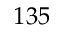<formula> <loc_0><loc_0><loc_500><loc_500>1 3 5</formula> 